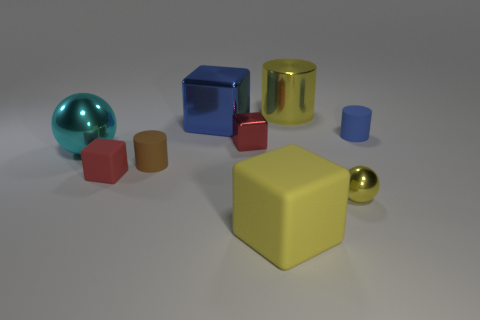Add 1 gray metallic things. How many objects exist? 10 Subtract all cylinders. How many objects are left? 6 Subtract 1 blue cubes. How many objects are left? 8 Subtract all brown matte cylinders. Subtract all small yellow spheres. How many objects are left? 7 Add 2 blue cubes. How many blue cubes are left? 3 Add 8 big cylinders. How many big cylinders exist? 9 